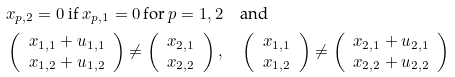<formula> <loc_0><loc_0><loc_500><loc_500>& x _ { p , 2 } = 0 \text { if } x _ { p , 1 } = 0 \, \text {for $p = 1, 2$} \quad \text {and} \\ & \left ( \begin{array} { c } x _ { 1 , 1 } + u _ { 1 , 1 } \\ x _ { 1 , 2 } + u _ { 1 , 2 } \end{array} \right ) \not = \left ( \begin{array} { c } x _ { 2 , 1 } \\ x _ { 2 , 2 } \end{array} \right ) , \quad \left ( \begin{array} { c } x _ { 1 , 1 } \\ x _ { 1 , 2 } \end{array} \right ) \not = \left ( \begin{array} { c } x _ { 2 , 1 } + u _ { 2 , 1 } \\ x _ { 2 , 2 } + u _ { 2 , 2 } \end{array} \right )</formula> 